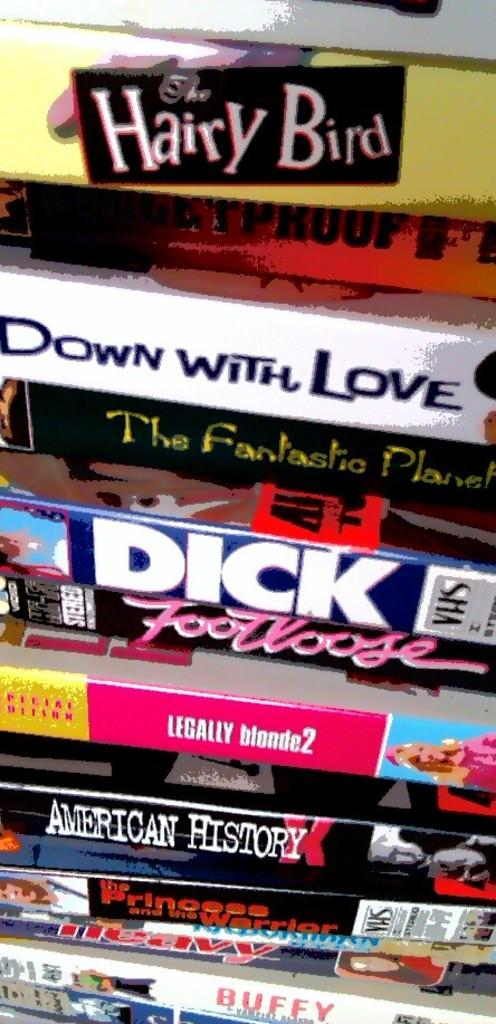<image>
Write a terse but informative summary of the picture. Many movies are in a large stack, including Hairy Bird, Down with Love, Legally Blonde 2, American History, and Footloose. 